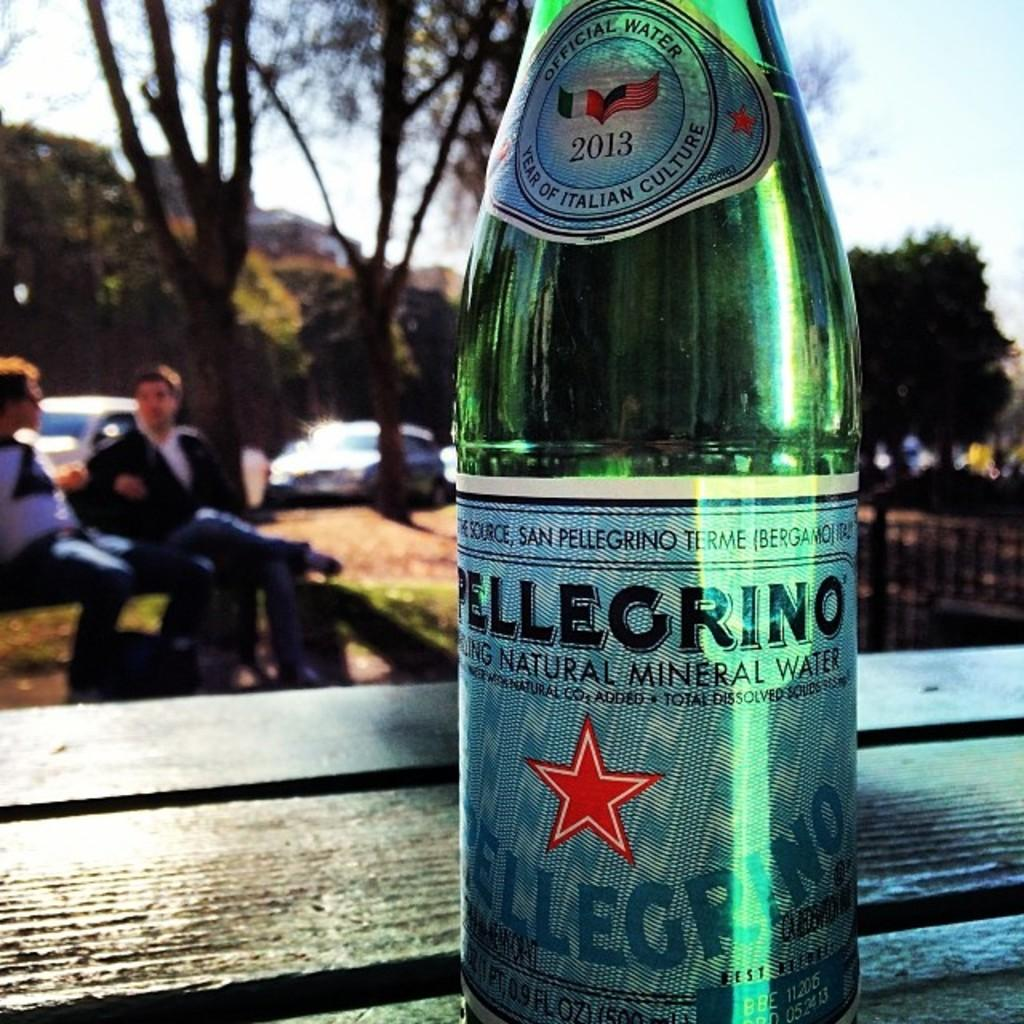What is the main focus of the picture? The bottle is highlighted in the picture. What can be seen in the background of the image? There are trees in the distance and vehicles visible in the distance. What are the two persons in the image doing? Two persons are sitting on a bench. Can you tell me how many mice are running around the bench in the image? There are no mice present in the image; it features a bottle, trees, vehicles, and two persons sitting on a bench. What invention is being demonstrated by the persons sitting on the bench? There is no invention being demonstrated in the image; the two persons are simply sitting on a bench. 